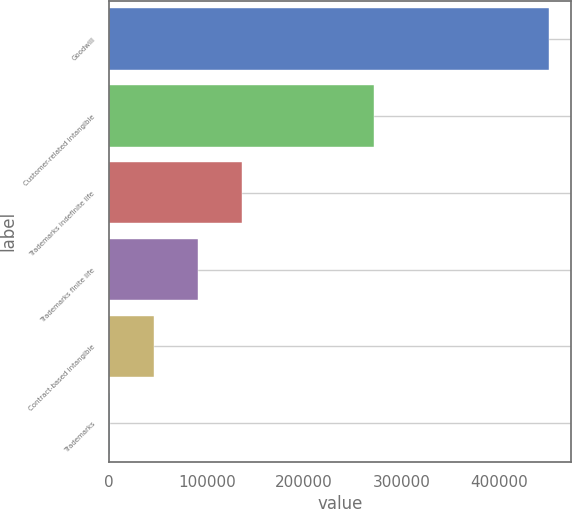Convert chart. <chart><loc_0><loc_0><loc_500><loc_500><bar_chart><fcel>Goodwill<fcel>Customer-related intangible<fcel>Trademarks indefinite life<fcel>Trademarks finite life<fcel>Contract-based intangible<fcel>Trademarks<nl><fcel>451244<fcel>271165<fcel>136266<fcel>91269.6<fcel>46272.8<fcel>1276<nl></chart> 